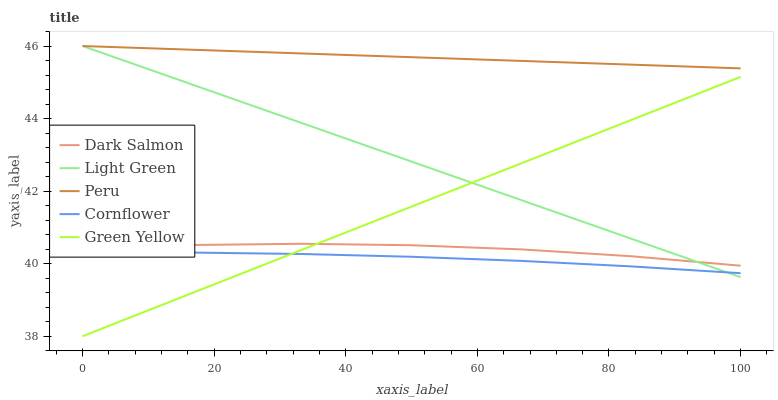Does Cornflower have the minimum area under the curve?
Answer yes or no. Yes. Does Peru have the maximum area under the curve?
Answer yes or no. Yes. Does Green Yellow have the minimum area under the curve?
Answer yes or no. No. Does Green Yellow have the maximum area under the curve?
Answer yes or no. No. Is Green Yellow the smoothest?
Answer yes or no. Yes. Is Dark Salmon the roughest?
Answer yes or no. Yes. Is Dark Salmon the smoothest?
Answer yes or no. No. Is Green Yellow the roughest?
Answer yes or no. No. Does Green Yellow have the lowest value?
Answer yes or no. Yes. Does Dark Salmon have the lowest value?
Answer yes or no. No. Does Light Green have the highest value?
Answer yes or no. Yes. Does Green Yellow have the highest value?
Answer yes or no. No. Is Dark Salmon less than Peru?
Answer yes or no. Yes. Is Peru greater than Green Yellow?
Answer yes or no. Yes. Does Green Yellow intersect Light Green?
Answer yes or no. Yes. Is Green Yellow less than Light Green?
Answer yes or no. No. Is Green Yellow greater than Light Green?
Answer yes or no. No. Does Dark Salmon intersect Peru?
Answer yes or no. No. 